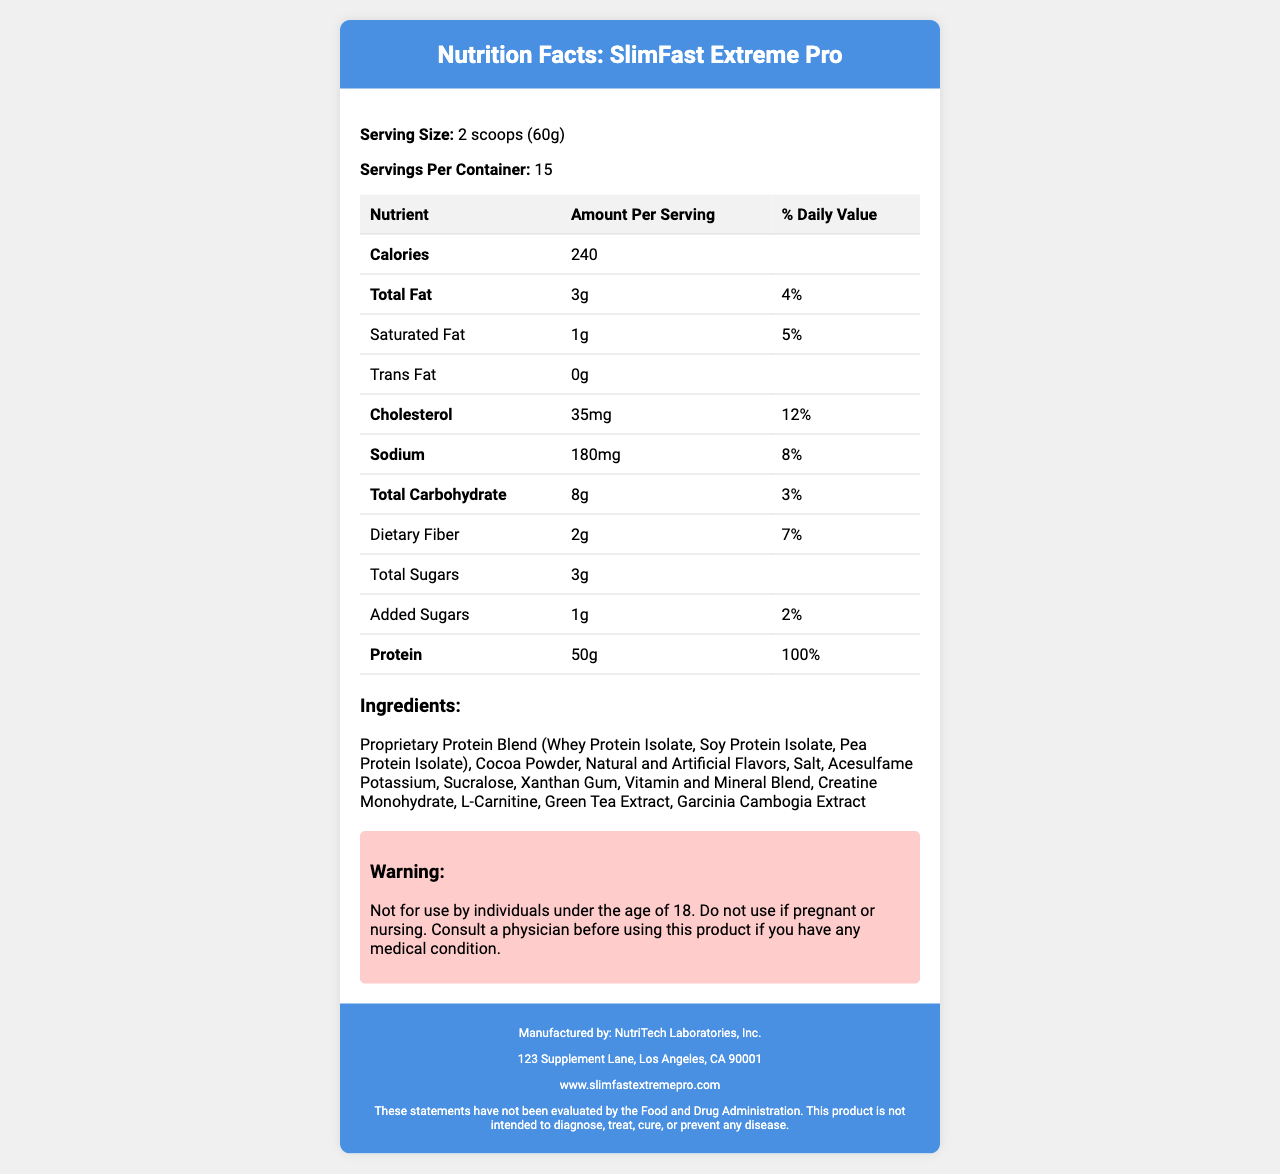what is the serving size? The serving size is mentioned at the beginning of the content under the "Serving Size" section.
Answer: 2 scoops (60g) how many servings per container are there? The number of servings per container is specified under the "Servings Per Container" section.
Answer: 15 what is the amount of protein per serving? The protein amount per serving is listed under the "Nutrient" table with a bold heading of "Protein".
Answer: 50g which company manufactures SlimFast Extreme Pro? The manufacturer information is located at the bottom of the document under the footer section.
Answer: NutriTech Laboratories, Inc. what allergens are contained in the product? The allergen information is clearly stated in the "Allergen Info" section.
Answer: milk and soy how many calories are there per serving? The calorie content per serving is specified at the top of the "Nutrient" table.
Answer: 240 Does this product contain any trans fat? The "Trans Fat" section of the table shows "0g", indicating the product does not contain any trans fat.
Answer: No which is the highest vitamin percentage in the product? A. Vitamin A B. Vitamin D C. Vitamin B12 D. Vitamin C Vitamin C has a daily value of 50%, which is the highest among the listed vitamins.
Answer: D what is the daily value percentage of calcium per serving? The daily value of calcium per serving is listed under the "Nutrient" table.
Answer: 20% is it recommended for pregnant or nursing women to use this product? The warning section states "Do not use if pregnant or nursing."
Answer: No what's the main idea of this document? The document is structured to provide a comprehensive overview of a weight loss supplement's nutritional facts, ingredient list, manufacturer details, and usage warnings.
Answer: The main idea of the document is to provide detailed nutritional information about the SlimFast Extreme Pro weight loss supplement, covering aspects like serving size, ingredients, allergen information, and manufacturer details. It also includes a warning about the product's usage. what is the manufacturer's address? The manufacturer's address is provided in the footer section of the document.
Answer: 123 Supplement Lane, Los Angeles, CA 90001 what ingredient types are included in the proprietary protein blend? A. Whey Protein Isolate, Soy Protein Isolate, Pea Protein Isolate B. Cocoa Powder, Sucralose, Salt C. Green Tea Extract, Garcinia Cambogia Extract, Creatine Monohydrate D. Vitamin and Mineral Blend, Acesulfame Potassium, Xanthan Gum The proprietary protein blend, which includes Whey Protein Isolate, Soy Protein Isolate, and Pea Protein Isolate, is listed first in the ingredients section.
Answer: A can you determine the shelf life of the product from the document? The document does not provide any details regarding the shelf life of the product, so this cannot be determined from the provided information.
Answer: Not enough information which website can you visit for more information about SlimFast Extreme Pro? The website information is located in the footer section of the document.
Answer: www.slimfastextremepro.com 